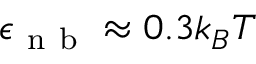Convert formula to latex. <formula><loc_0><loc_0><loc_500><loc_500>\epsilon _ { n b } \approx 0 . 3 k _ { B } T</formula> 